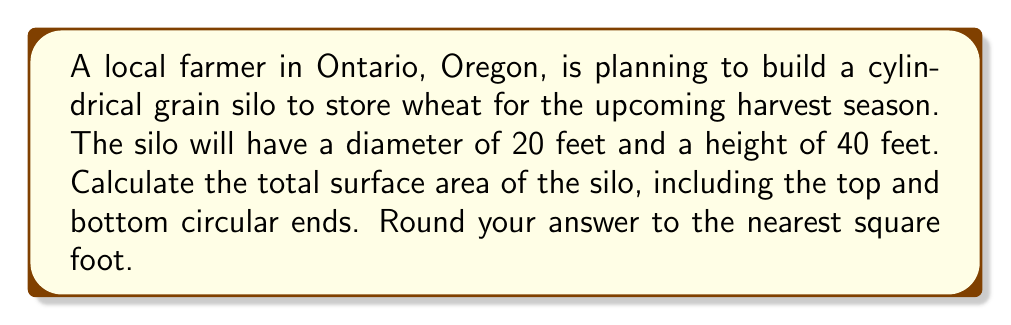Solve this math problem. To calculate the surface area of a cylindrical grain silo, we need to consider three parts:
1. The lateral surface area (curved side)
2. The top circular area
3. The bottom circular area

Let's break it down step-by-step:

1. Lateral surface area:
   The formula for the lateral surface area of a cylinder is $A_l = 2\pi rh$, where $r$ is the radius and $h$ is the height.
   
   Radius $r = \frac{\text{diameter}}{2} = \frac{20}{2} = 10$ feet
   Height $h = 40$ feet
   
   $$A_l = 2\pi(10)(40) = 800\pi \approx 2513.27 \text{ sq ft}$$

2. Top and bottom circular areas:
   The formula for the area of a circle is $A_c = \pi r^2$
   
   $$A_c = \pi(10^2) = 100\pi \approx 314.16 \text{ sq ft}$$
   
   We need to calculate this twice (for top and bottom), so: $2A_c = 200\pi \approx 628.32 \text{ sq ft}$

3. Total surface area:
   Add the lateral surface area and the areas of both circular ends:
   
   $$A_{\text{total}} = A_l + 2A_c = 800\pi + 200\pi = 1000\pi \approx 3141.59 \text{ sq ft}$$

Rounding to the nearest square foot, we get 3,142 sq ft.
Answer: 3,142 square feet 